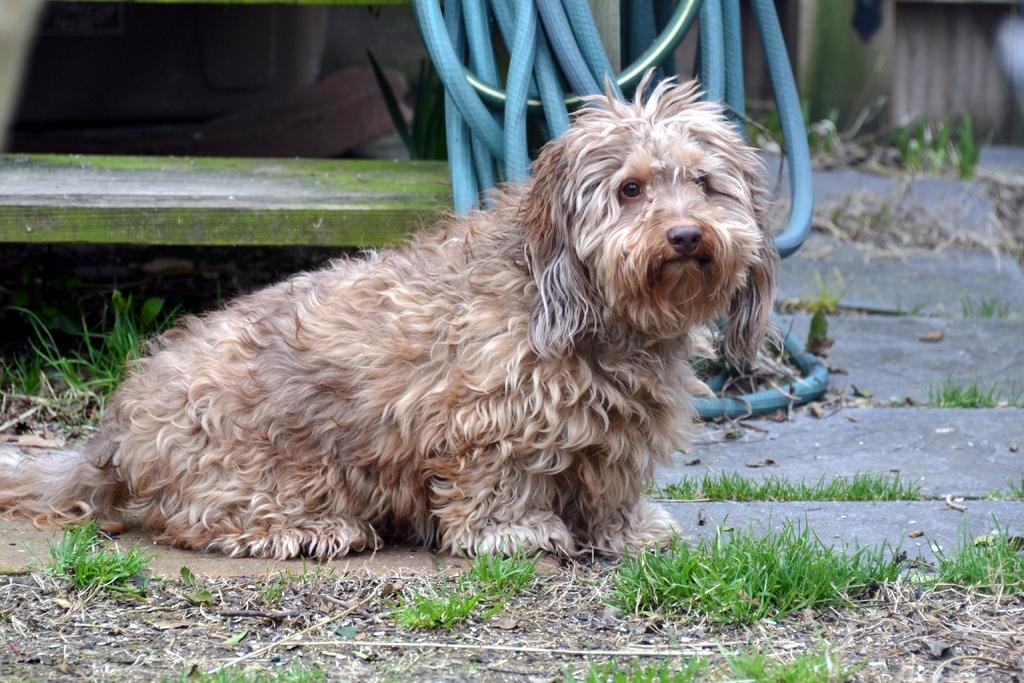What animal can be seen in the image? There is a dog in the image. What is the dog standing or sitting on? The dog is on a surface in the image. What type of vegetation is visible in the image? Grass is visible in the image. What man-made object can be seen in the image? There is a pipe in the image. What type of seating is present in the image? There is a wooden bench in the image. What grade does the dog receive for its performance in the image? There is no grading system or performance evaluation present in the image, as it features a dog and other objects. 